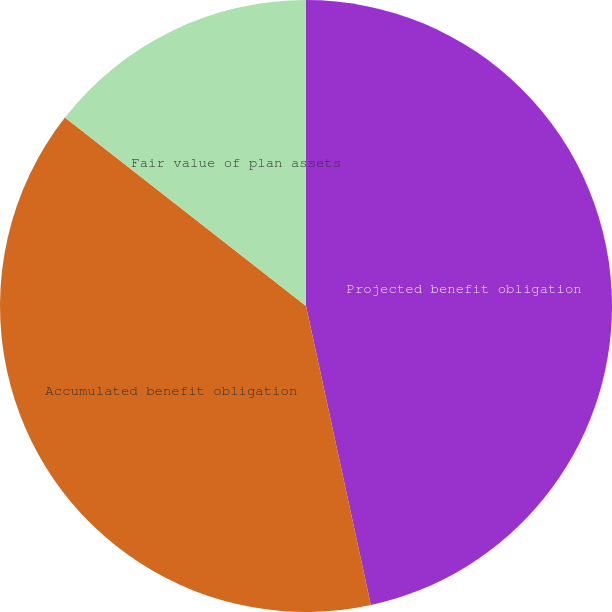<chart> <loc_0><loc_0><loc_500><loc_500><pie_chart><fcel>Projected benefit obligation<fcel>Accumulated benefit obligation<fcel>Fair value of plan assets<nl><fcel>46.6%<fcel>38.96%<fcel>14.44%<nl></chart> 